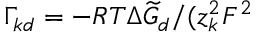Convert formula to latex. <formula><loc_0><loc_0><loc_500><loc_500>\Gamma _ { k d } = - { R T \Delta \widetilde { G } _ { d } } / ( z _ { k } ^ { 2 } F ^ { 2 }</formula> 